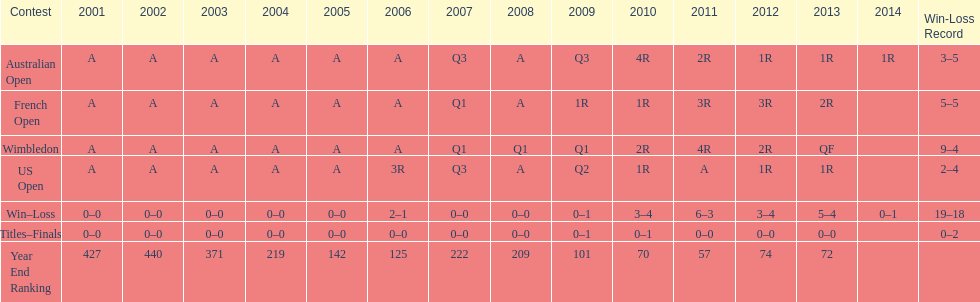What was the total number of matches played from 2001 to 2014? 37. Would you be able to parse every entry in this table? {'header': ['Contest', '2001', '2002', '2003', '2004', '2005', '2006', '2007', '2008', '2009', '2010', '2011', '2012', '2013', '2014', 'Win-Loss Record'], 'rows': [['Australian Open', 'A', 'A', 'A', 'A', 'A', 'A', 'Q3', 'A', 'Q3', '4R', '2R', '1R', '1R', '1R', '3–5'], ['French Open', 'A', 'A', 'A', 'A', 'A', 'A', 'Q1', 'A', '1R', '1R', '3R', '3R', '2R', '', '5–5'], ['Wimbledon', 'A', 'A', 'A', 'A', 'A', 'A', 'Q1', 'Q1', 'Q1', '2R', '4R', '2R', 'QF', '', '9–4'], ['US Open', 'A', 'A', 'A', 'A', 'A', '3R', 'Q3', 'A', 'Q2', '1R', 'A', '1R', '1R', '', '2–4'], ['Win–Loss', '0–0', '0–0', '0–0', '0–0', '0–0', '2–1', '0–0', '0–0', '0–1', '3–4', '6–3', '3–4', '5–4', '0–1', '19–18'], ['Titles–Finals', '0–0', '0–0', '0–0', '0–0', '0–0', '0–0', '0–0', '0–0', '0–1', '0–1', '0–0', '0–0', '0–0', '', '0–2'], ['Year End Ranking', '427', '440', '371', '219', '142', '125', '222', '209', '101', '70', '57', '74', '72', '', '']]} 